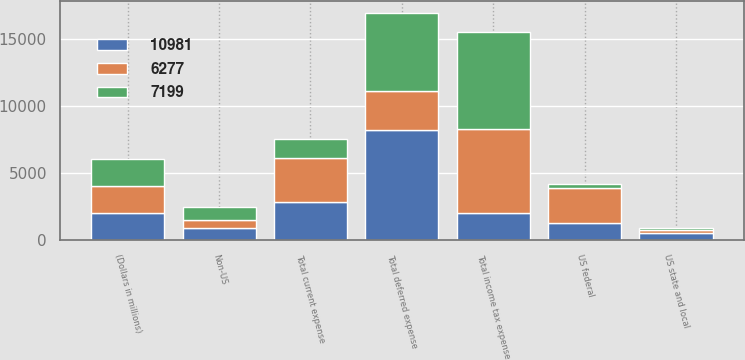<chart> <loc_0><loc_0><loc_500><loc_500><stacked_bar_chart><ecel><fcel>(Dollars in millions)<fcel>US federal<fcel>US state and local<fcel>Non-US<fcel>Total current expense<fcel>Total deferred expense<fcel>Total income tax expense<nl><fcel>10981<fcel>2017<fcel>1310<fcel>557<fcel>939<fcel>2806<fcel>8175<fcel>2015.5<nl><fcel>7199<fcel>2016<fcel>302<fcel>120<fcel>984<fcel>1406<fcel>5793<fcel>7199<nl><fcel>6277<fcel>2015<fcel>2539<fcel>210<fcel>561<fcel>3310<fcel>2967<fcel>6277<nl></chart> 